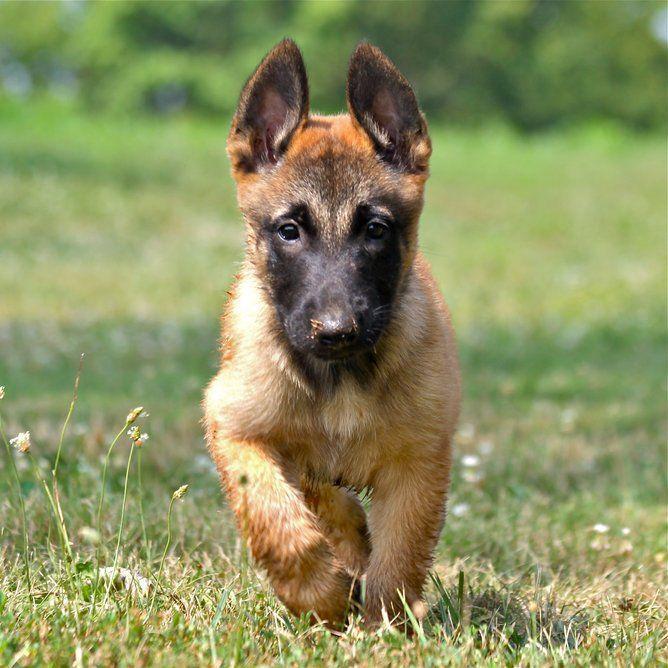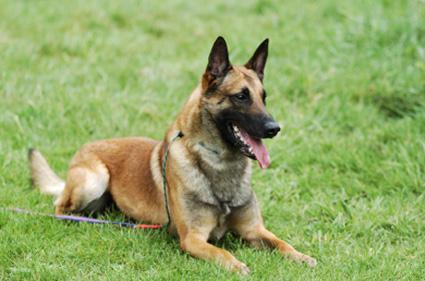The first image is the image on the left, the second image is the image on the right. Analyze the images presented: Is the assertion "There is one dog standing still on all fours in the stacked position." valid? Answer yes or no. No. 